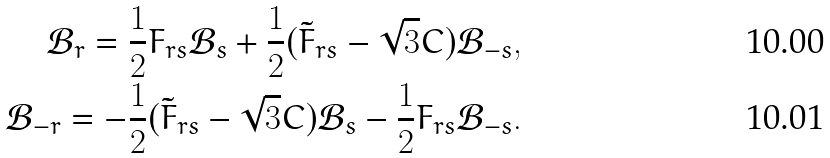Convert formula to latex. <formula><loc_0><loc_0><loc_500><loc_500>\mathcal { B } _ { r } = \frac { 1 } { 2 } F _ { r s } \mathcal { B } _ { s } + \frac { 1 } { 2 } ( \tilde { F } _ { r s } - \sqrt { 3 } C ) \mathcal { B } _ { - s } , \\ \mathcal { B } _ { - r } = - \frac { 1 } { 2 } ( \tilde { F } _ { r s } - \sqrt { 3 } C ) \mathcal { B } _ { s } - \frac { 1 } { 2 } F _ { r s } \mathcal { B } _ { - s } .</formula> 